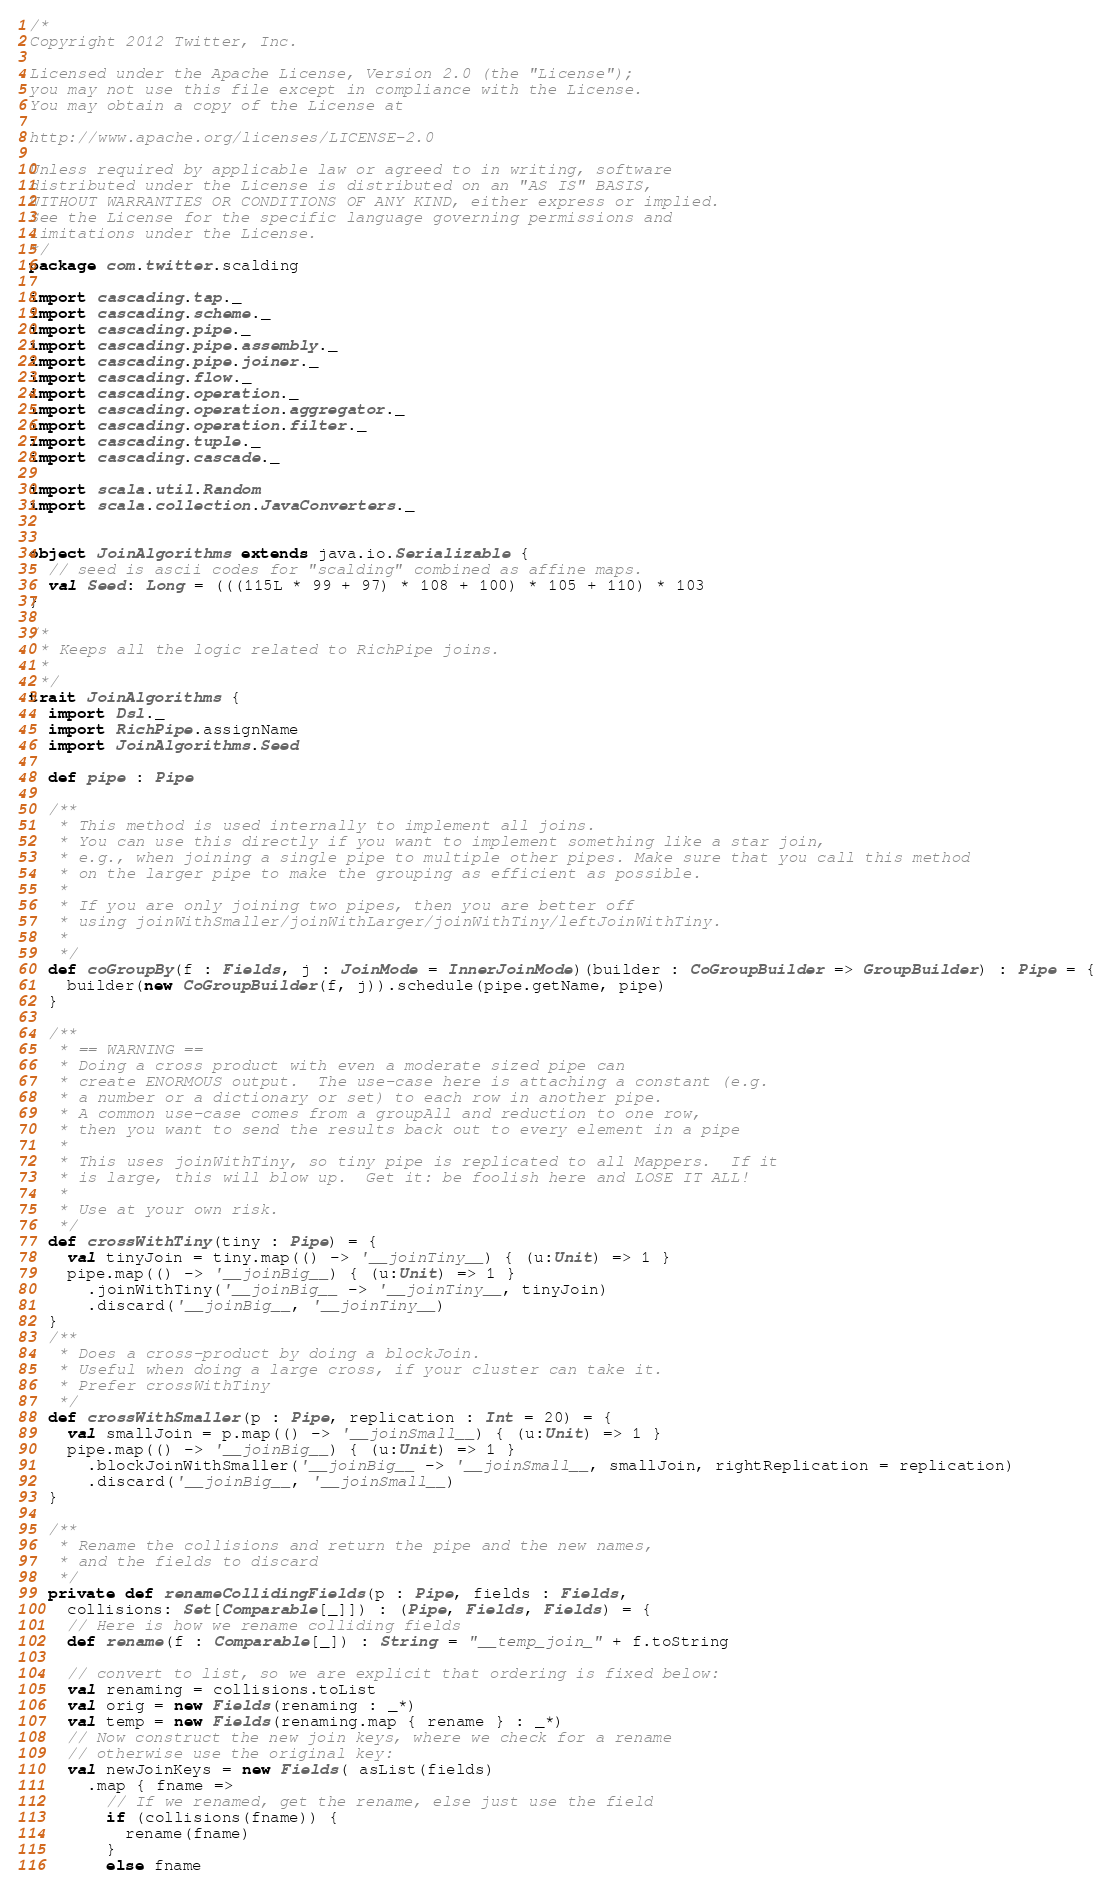Convert code to text. <code><loc_0><loc_0><loc_500><loc_500><_Scala_>/*
Copyright 2012 Twitter, Inc.

Licensed under the Apache License, Version 2.0 (the "License");
you may not use this file except in compliance with the License.
You may obtain a copy of the License at

http://www.apache.org/licenses/LICENSE-2.0

Unless required by applicable law or agreed to in writing, software
distributed under the License is distributed on an "AS IS" BASIS,
WITHOUT WARRANTIES OR CONDITIONS OF ANY KIND, either express or implied.
See the License for the specific language governing permissions and
limitations under the License.
*/
package com.twitter.scalding

import cascading.tap._
import cascading.scheme._
import cascading.pipe._
import cascading.pipe.assembly._
import cascading.pipe.joiner._
import cascading.flow._
import cascading.operation._
import cascading.operation.aggregator._
import cascading.operation.filter._
import cascading.tuple._
import cascading.cascade._

import scala.util.Random
import scala.collection.JavaConverters._


object JoinAlgorithms extends java.io.Serializable {
  // seed is ascii codes for "scalding" combined as affine maps.
  val Seed: Long = (((115L * 99 + 97) * 108 + 100) * 105 + 110) * 103
}

/*
 * Keeps all the logic related to RichPipe joins.
 *
 */
trait JoinAlgorithms {
  import Dsl._
  import RichPipe.assignName
  import JoinAlgorithms.Seed

  def pipe : Pipe

  /**
   * This method is used internally to implement all joins.
   * You can use this directly if you want to implement something like a star join,
   * e.g., when joining a single pipe to multiple other pipes. Make sure that you call this method
   * on the larger pipe to make the grouping as efficient as possible.
   *
   * If you are only joining two pipes, then you are better off
   * using joinWithSmaller/joinWithLarger/joinWithTiny/leftJoinWithTiny.
   *
   */
  def coGroupBy(f : Fields, j : JoinMode = InnerJoinMode)(builder : CoGroupBuilder => GroupBuilder) : Pipe = {
    builder(new CoGroupBuilder(f, j)).schedule(pipe.getName, pipe)
  }

  /**
   * == WARNING ==
   * Doing a cross product with even a moderate sized pipe can
   * create ENORMOUS output.  The use-case here is attaching a constant (e.g.
   * a number or a dictionary or set) to each row in another pipe.
   * A common use-case comes from a groupAll and reduction to one row,
   * then you want to send the results back out to every element in a pipe
   *
   * This uses joinWithTiny, so tiny pipe is replicated to all Mappers.  If it
   * is large, this will blow up.  Get it: be foolish here and LOSE IT ALL!
   *
   * Use at your own risk.
   */
  def crossWithTiny(tiny : Pipe) = {
    val tinyJoin = tiny.map(() -> '__joinTiny__) { (u:Unit) => 1 }
    pipe.map(() -> '__joinBig__) { (u:Unit) => 1 }
      .joinWithTiny('__joinBig__ -> '__joinTiny__, tinyJoin)
      .discard('__joinBig__, '__joinTiny__)
  }
  /**
   * Does a cross-product by doing a blockJoin.
   * Useful when doing a large cross, if your cluster can take it.
   * Prefer crossWithTiny
   */
  def crossWithSmaller(p : Pipe, replication : Int = 20) = {
    val smallJoin = p.map(() -> '__joinSmall__) { (u:Unit) => 1 }
    pipe.map(() -> '__joinBig__) { (u:Unit) => 1 }
      .blockJoinWithSmaller('__joinBig__ -> '__joinSmall__, smallJoin, rightReplication = replication)
      .discard('__joinBig__, '__joinSmall__)
  }

  /**
   * Rename the collisions and return the pipe and the new names,
   * and the fields to discard
   */
  private def renameCollidingFields(p : Pipe, fields : Fields,
    collisions: Set[Comparable[_]]) : (Pipe, Fields, Fields) = {
    // Here is how we rename colliding fields
    def rename(f : Comparable[_]) : String = "__temp_join_" + f.toString

    // convert to list, so we are explicit that ordering is fixed below:
    val renaming = collisions.toList
    val orig = new Fields(renaming : _*)
    val temp = new Fields(renaming.map { rename } : _*)
    // Now construct the new join keys, where we check for a rename
    // otherwise use the original key:
    val newJoinKeys = new Fields( asList(fields)
      .map { fname =>
        // If we renamed, get the rename, else just use the field
        if (collisions(fname)) {
          rename(fname)
        }
        else fname</code> 